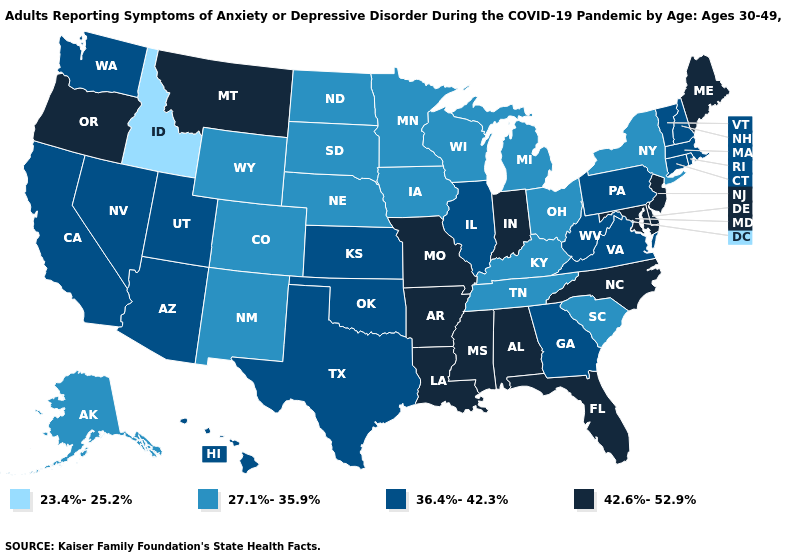What is the highest value in the West ?
Write a very short answer. 42.6%-52.9%. What is the value of Alabama?
Write a very short answer. 42.6%-52.9%. Which states hav the highest value in the South?
Give a very brief answer. Alabama, Arkansas, Delaware, Florida, Louisiana, Maryland, Mississippi, North Carolina. Which states have the lowest value in the West?
Quick response, please. Idaho. What is the lowest value in the USA?
Keep it brief. 23.4%-25.2%. Does Wisconsin have the lowest value in the MidWest?
Write a very short answer. Yes. Name the states that have a value in the range 23.4%-25.2%?
Quick response, please. Idaho. What is the value of Florida?
Short answer required. 42.6%-52.9%. What is the lowest value in states that border Illinois?
Keep it brief. 27.1%-35.9%. Does Wisconsin have a higher value than Florida?
Give a very brief answer. No. What is the lowest value in the USA?
Be succinct. 23.4%-25.2%. Does the first symbol in the legend represent the smallest category?
Give a very brief answer. Yes. Among the states that border South Carolina , which have the lowest value?
Quick response, please. Georgia. What is the highest value in states that border Connecticut?
Give a very brief answer. 36.4%-42.3%. Which states have the lowest value in the USA?
Keep it brief. Idaho. 